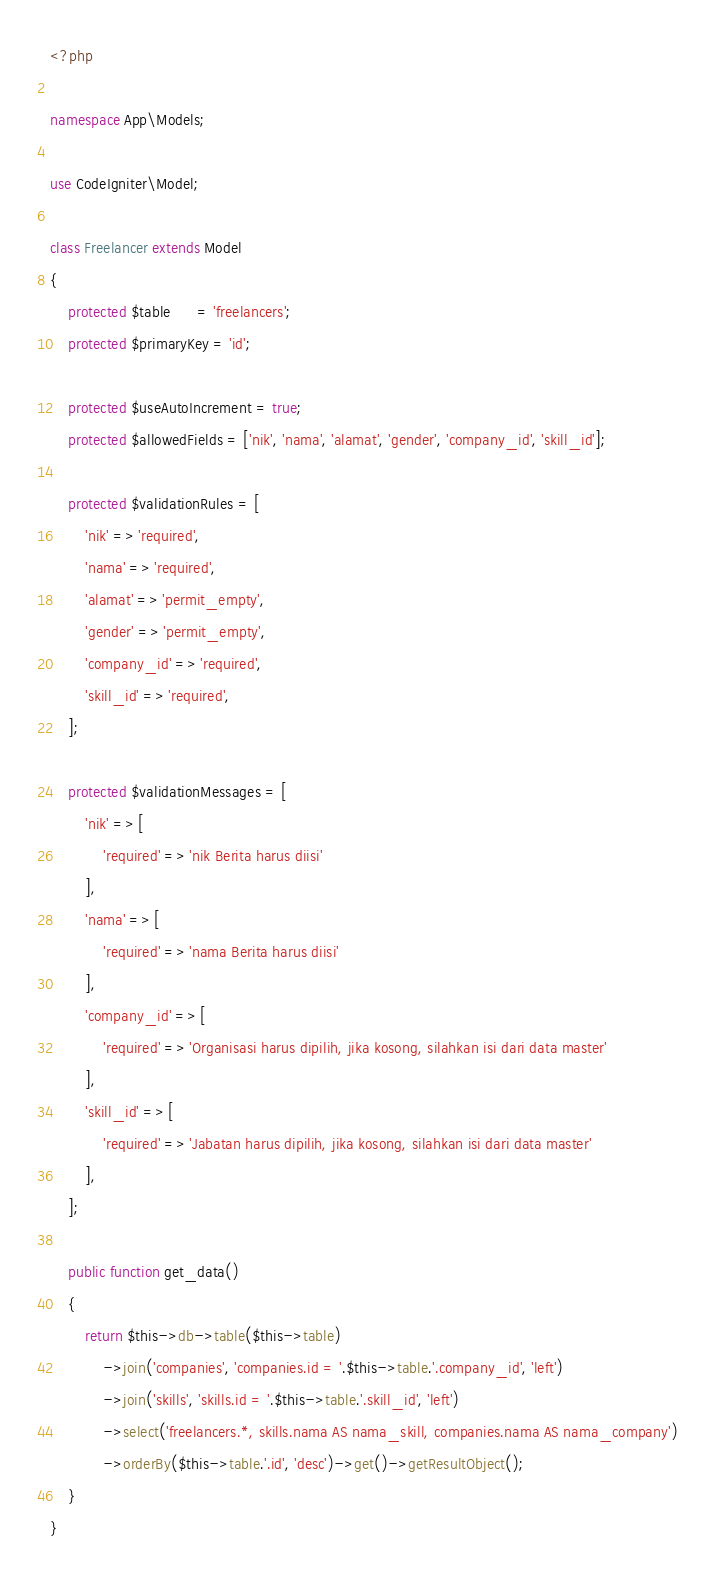<code> <loc_0><loc_0><loc_500><loc_500><_PHP_><?php

namespace App\Models;

use CodeIgniter\Model;

class Freelancer extends Model
{
    protected $table      = 'freelancers';
    protected $primaryKey = 'id';

    protected $useAutoIncrement = true;
    protected $allowedFields = ['nik', 'nama', 'alamat', 'gender', 'company_id', 'skill_id'];

    protected $validationRules = [
        'nik' => 'required',
        'nama' => 'required',
        'alamat' => 'permit_empty',
        'gender' => 'permit_empty',
        'company_id' => 'required',
        'skill_id' => 'required',
    ];

    protected $validationMessages = [
        'nik' => [
            'required' => 'nik Berita harus diisi'
        ],
        'nama' => [
            'required' => 'nama Berita harus diisi'
        ],
        'company_id' => [
            'required' => 'Organisasi harus dipilih, jika kosong, silahkan isi dari data master'
        ],
        'skill_id' => [
            'required' => 'Jabatan harus dipilih, jika kosong, silahkan isi dari data master'
        ],
    ];

    public function get_data()
    {
    	return $this->db->table($this->table)
	    	->join('companies', 'companies.id = '.$this->table.'.company_id', 'left')
	    	->join('skills', 'skills.id = '.$this->table.'.skill_id', 'left')
            ->select('freelancers.*, skills.nama AS nama_skill, companies.nama AS nama_company')
	    	->orderBy($this->table.'.id', 'desc')->get()->getResultObject();
    }
}
</code> 